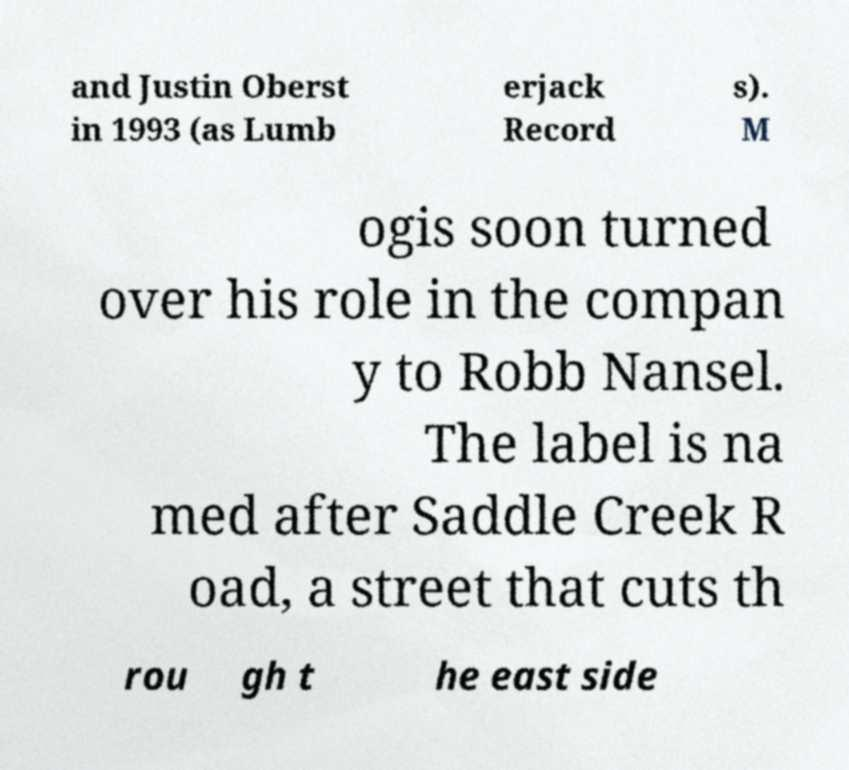For documentation purposes, I need the text within this image transcribed. Could you provide that? and Justin Oberst in 1993 (as Lumb erjack Record s). M ogis soon turned over his role in the compan y to Robb Nansel. The label is na med after Saddle Creek R oad, a street that cuts th rou gh t he east side 